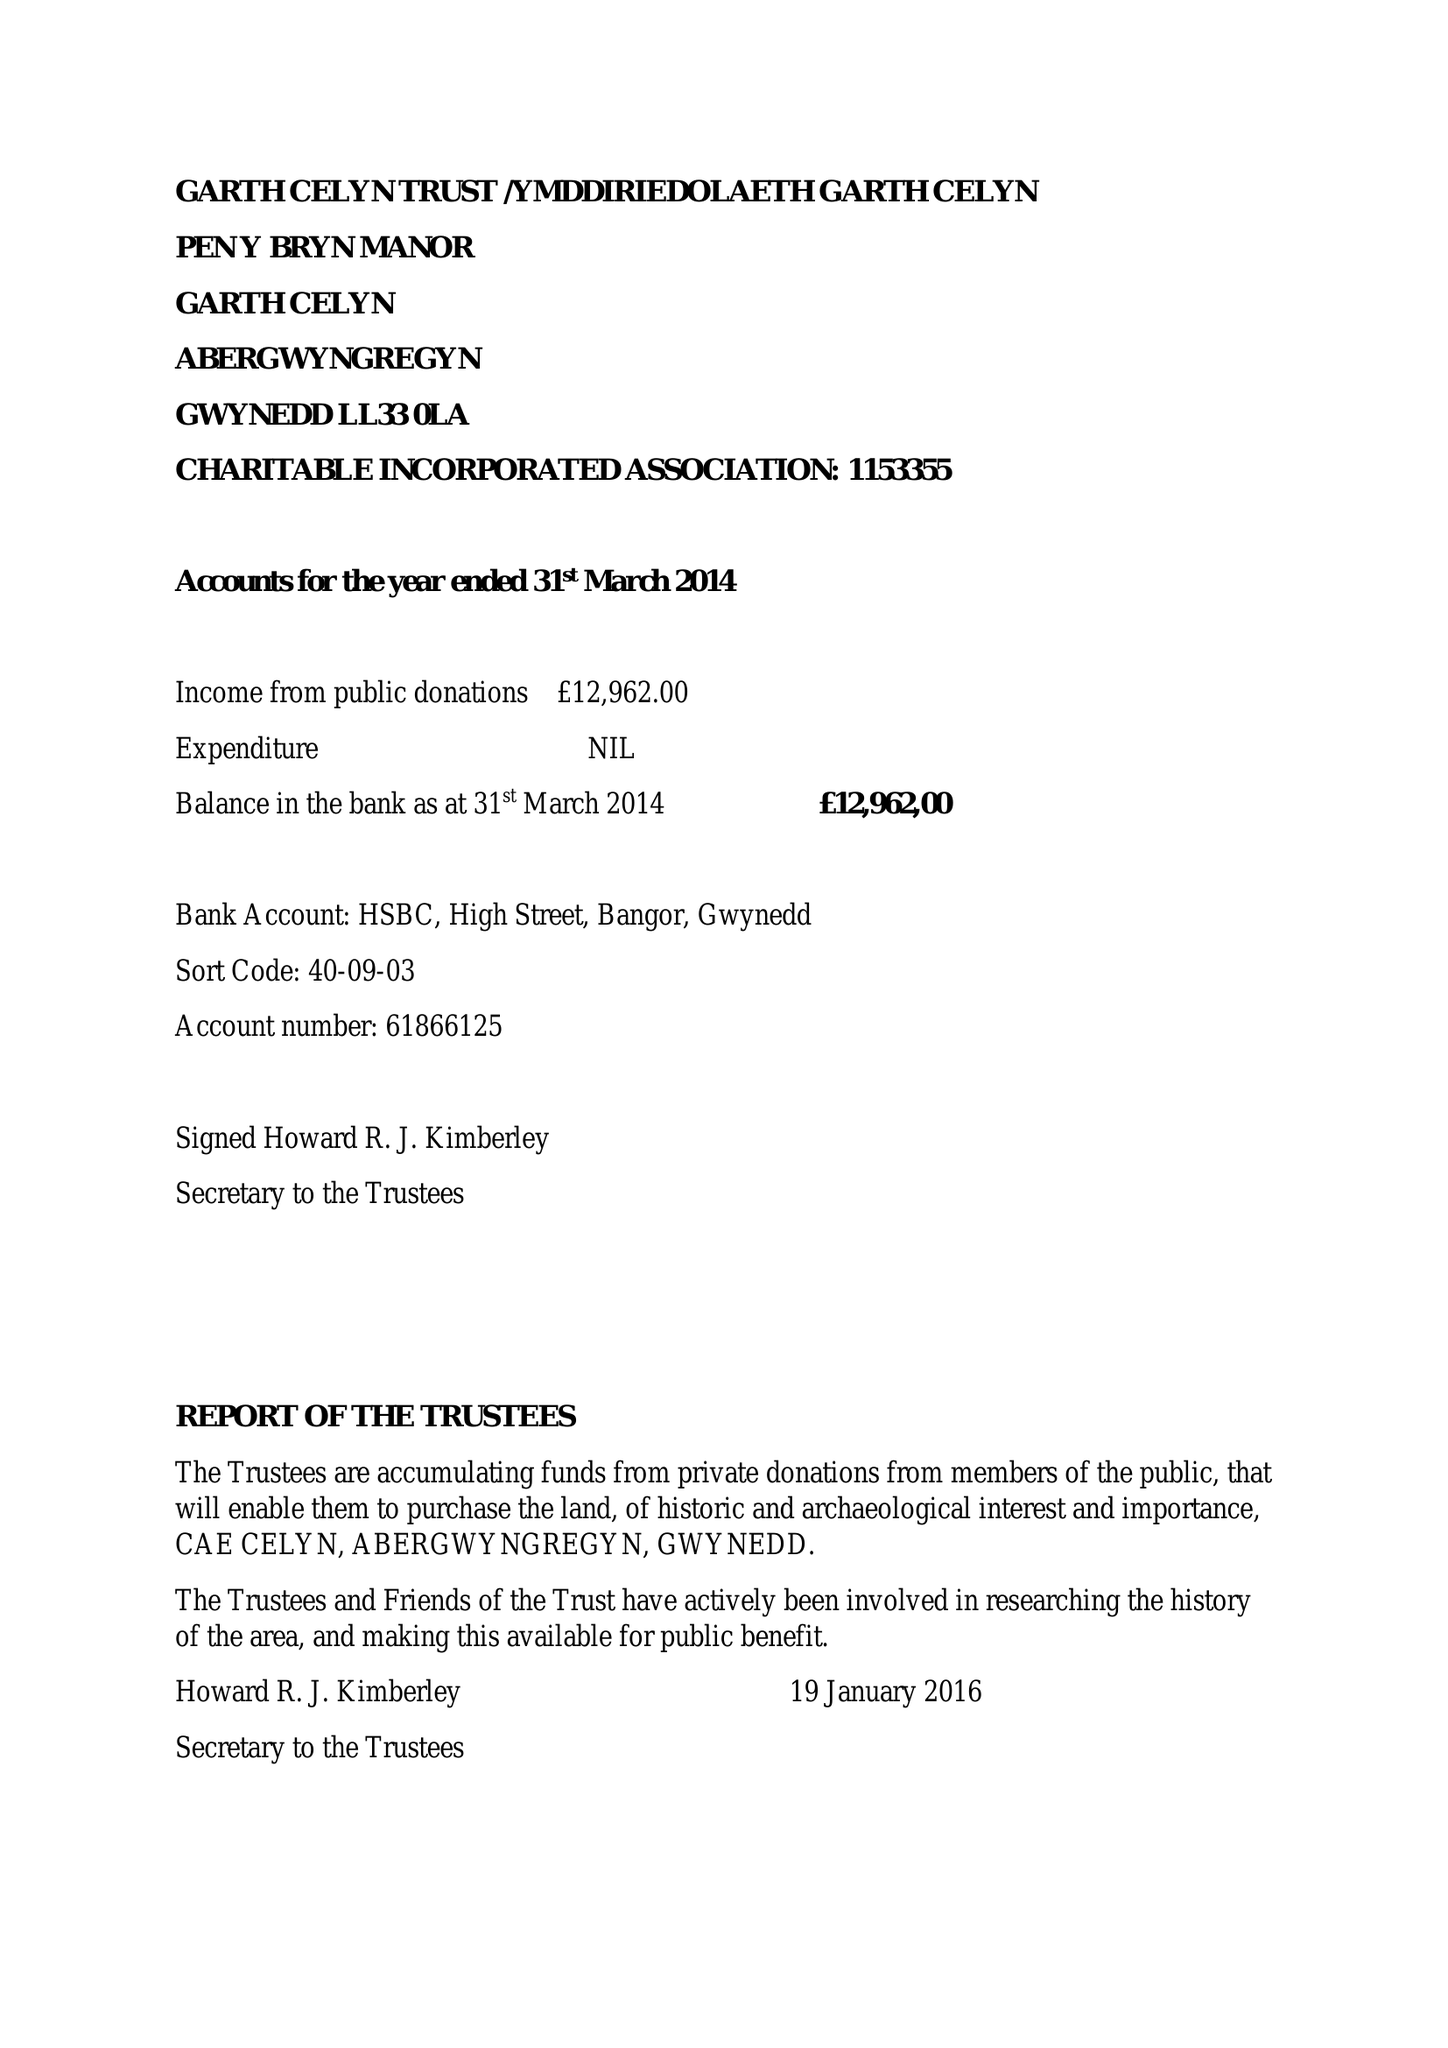What is the value for the charity_number?
Answer the question using a single word or phrase. 1153355 